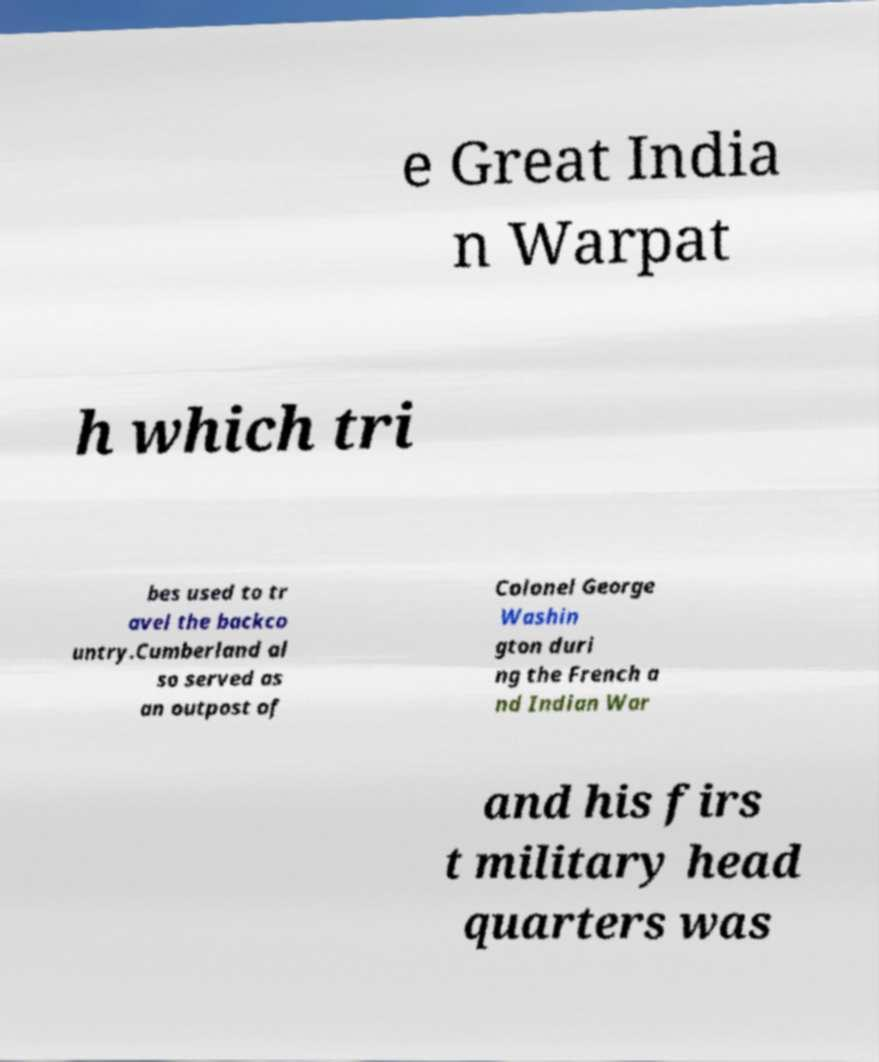For documentation purposes, I need the text within this image transcribed. Could you provide that? e Great India n Warpat h which tri bes used to tr avel the backco untry.Cumberland al so served as an outpost of Colonel George Washin gton duri ng the French a nd Indian War and his firs t military head quarters was 